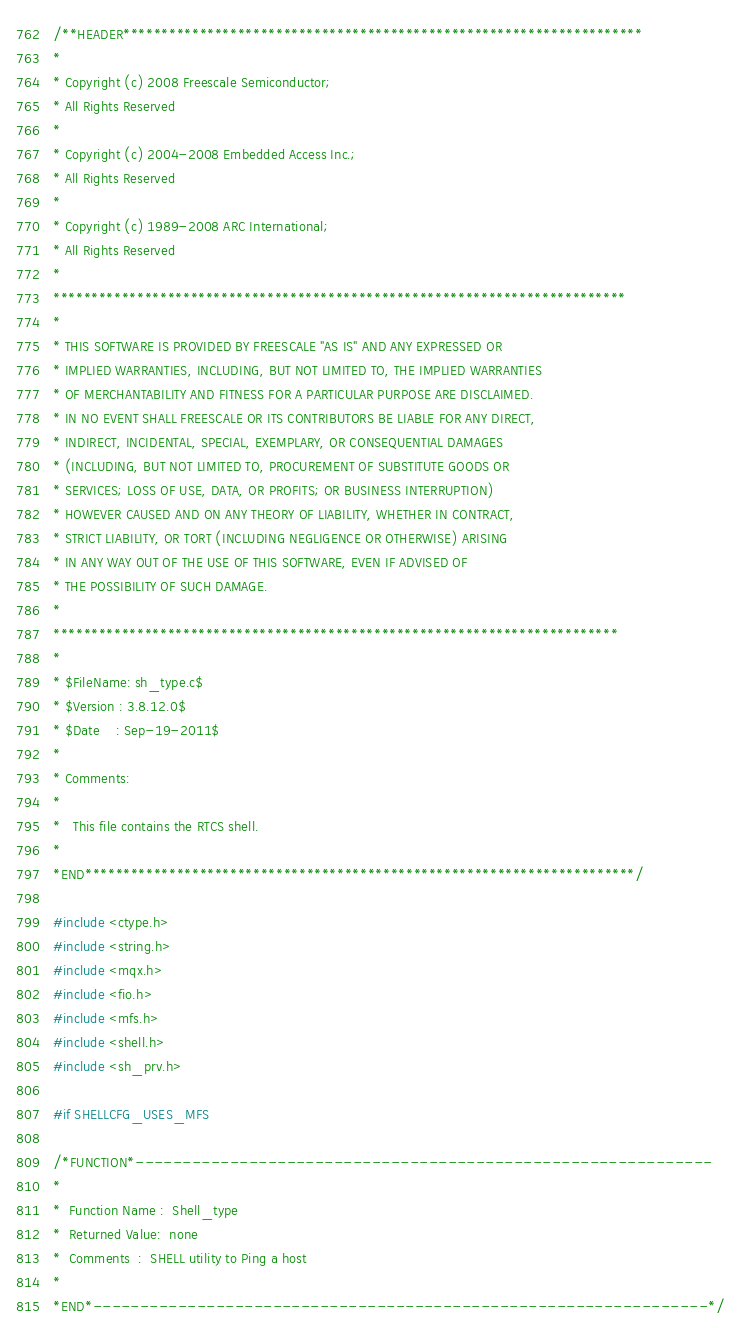Convert code to text. <code><loc_0><loc_0><loc_500><loc_500><_C_>/**HEADER********************************************************************
* 
* Copyright (c) 2008 Freescale Semiconductor;
* All Rights Reserved                       
*
* Copyright (c) 2004-2008 Embedded Access Inc.;
* All Rights Reserved
*
* Copyright (c) 1989-2008 ARC International;
* All Rights Reserved
*
*************************************************************************** 
*
* THIS SOFTWARE IS PROVIDED BY FREESCALE "AS IS" AND ANY EXPRESSED OR 
* IMPLIED WARRANTIES, INCLUDING, BUT NOT LIMITED TO, THE IMPLIED WARRANTIES 
* OF MERCHANTABILITY AND FITNESS FOR A PARTICULAR PURPOSE ARE DISCLAIMED.  
* IN NO EVENT SHALL FREESCALE OR ITS CONTRIBUTORS BE LIABLE FOR ANY DIRECT, 
* INDIRECT, INCIDENTAL, SPECIAL, EXEMPLARY, OR CONSEQUENTIAL DAMAGES 
* (INCLUDING, BUT NOT LIMITED TO, PROCUREMENT OF SUBSTITUTE GOODS OR 
* SERVICES; LOSS OF USE, DATA, OR PROFITS; OR BUSINESS INTERRUPTION) 
* HOWEVER CAUSED AND ON ANY THEORY OF LIABILITY, WHETHER IN CONTRACT, 
* STRICT LIABILITY, OR TORT (INCLUDING NEGLIGENCE OR OTHERWISE) ARISING 
* IN ANY WAY OUT OF THE USE OF THIS SOFTWARE, EVEN IF ADVISED OF 
* THE POSSIBILITY OF SUCH DAMAGE.
*
**************************************************************************
*
* $FileName: sh_type.c$
* $Version : 3.8.12.0$
* $Date    : Sep-19-2011$
*
* Comments:
*
*   This file contains the RTCS shell.
*
*END************************************************************************/

#include <ctype.h>
#include <string.h>
#include <mqx.h>
#include <fio.h>
#include <mfs.h>
#include <shell.h>
#include <sh_prv.h>

#if SHELLCFG_USES_MFS

/*FUNCTION*-------------------------------------------------------------
*
*  Function Name :  Shell_type
*  Returned Value:  none
*  Comments  :  SHELL utility to Ping a host
*
*END*-----------------------------------------------------------------*/
</code> 